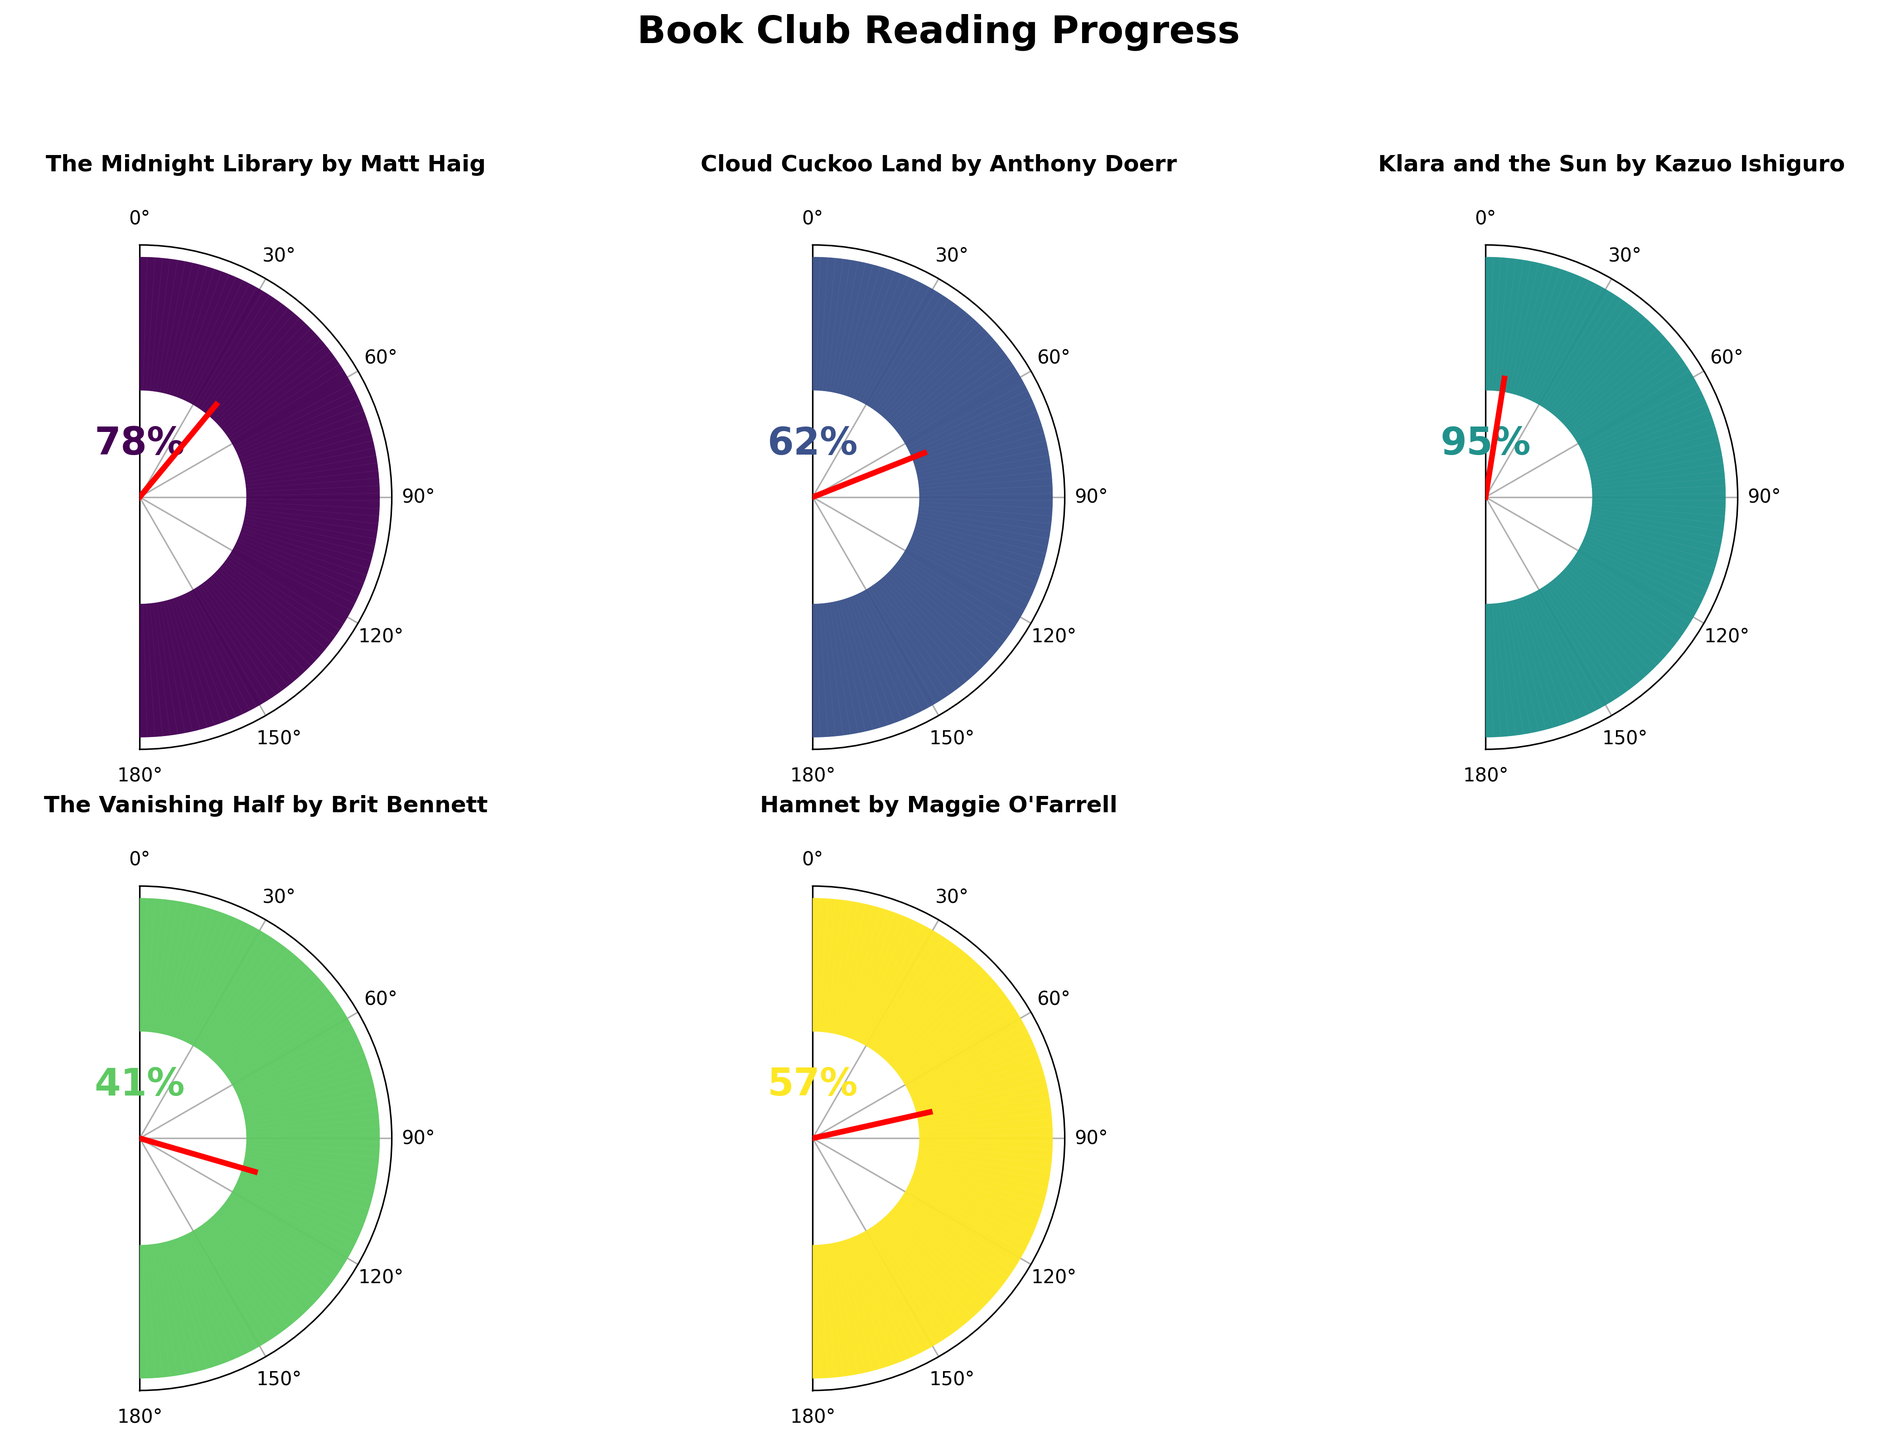What is the title of the book with the highest percentage completed? "Klara and the Sun" has the highest percentage completed of 95%, which can be determined by observing the gauge charts and identifying the one with the needle closest to 100%.
Answer: "Klara and the Sun" Which book has the lowest percentage of completion, and what is that percentage? "The Vanishing Half" has the lowest completion percentage at 41%, as seen from its gauge chart needle position being the furthest from 100%.
Answer: "The Vanishing Half", 41% What is the average percentage completed for all books? First, sum all completion percentages: 78 + 62 + 95 + 41 + 57 = 333. Then, divide by the number of books, which is 5: 333 / 5 = 66.6%.
Answer: 66.6% Compare the completion percentages of "Hamnet" and "Cloud Cuckoo Land". Which book has a higher percentage and by how much? "Hamnet" has a completion percentage of 57%, whereas "Cloud Cuckoo Land" has 62%. The difference is 62% - 57% = 5%. Therefore, "Cloud Cuckoo Land" is higher by 5%.
Answer: "Cloud Cuckoo Land" by 5% What is the median completion percentage among the books? To find the median, first order the completion percentages: 41, 57, 62, 78, 95. With five elements, the median is the third element in the sorted order, which is 62%.
Answer: 62% How many books have completion percentages above 50%? By observing the gauge charts, we can see that four books ("The Midnight Library", "Cloud Cuckoo Land", "Klara and the Sun", and "Hamnet") have completion percentages above 50%.
Answer: 4 Which book’s completion percentage is closest to 75%? "The Midnight Library" has a completion percentage of 78%, which is closest to 75% when comparing it to the percentages shown in the gauge charts.
Answer: "The Midnight Library" If you combine the completion percentages of the first two books, what will their total percentage be? The combined total of "The Midnight Library" (78%) and "Cloud Cuckoo Land" (62%) is 78 + 62 = 140%.
Answer: 140% Which of the books has a completion percentage closest to the average percentage completed? The average completion percentage is 66.6%. "Cloud Cuckoo Land" with 62% is the closest to this value.
Answer: "Cloud Cuckoo Land" In the gauge chart, which book has the needle closest to horizontal? "Hamnet" has the needle closest to horizontal, which in this context (and gauge design) corresponds to 50%, and its completion percentage is 57% making it appear closest to horizontal.
Answer: "Hamnet" 